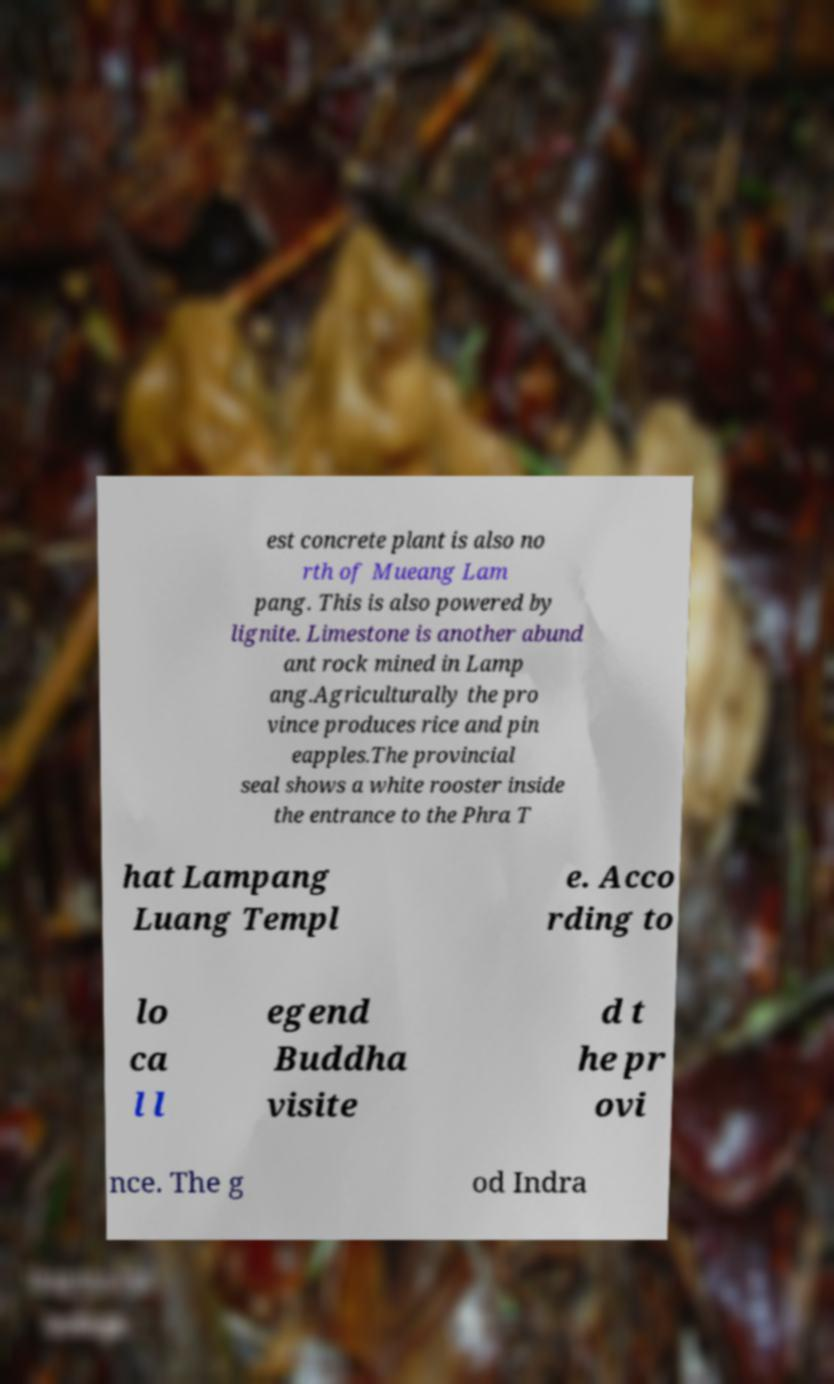Can you read and provide the text displayed in the image?This photo seems to have some interesting text. Can you extract and type it out for me? est concrete plant is also no rth of Mueang Lam pang. This is also powered by lignite. Limestone is another abund ant rock mined in Lamp ang.Agriculturally the pro vince produces rice and pin eapples.The provincial seal shows a white rooster inside the entrance to the Phra T hat Lampang Luang Templ e. Acco rding to lo ca l l egend Buddha visite d t he pr ovi nce. The g od Indra 